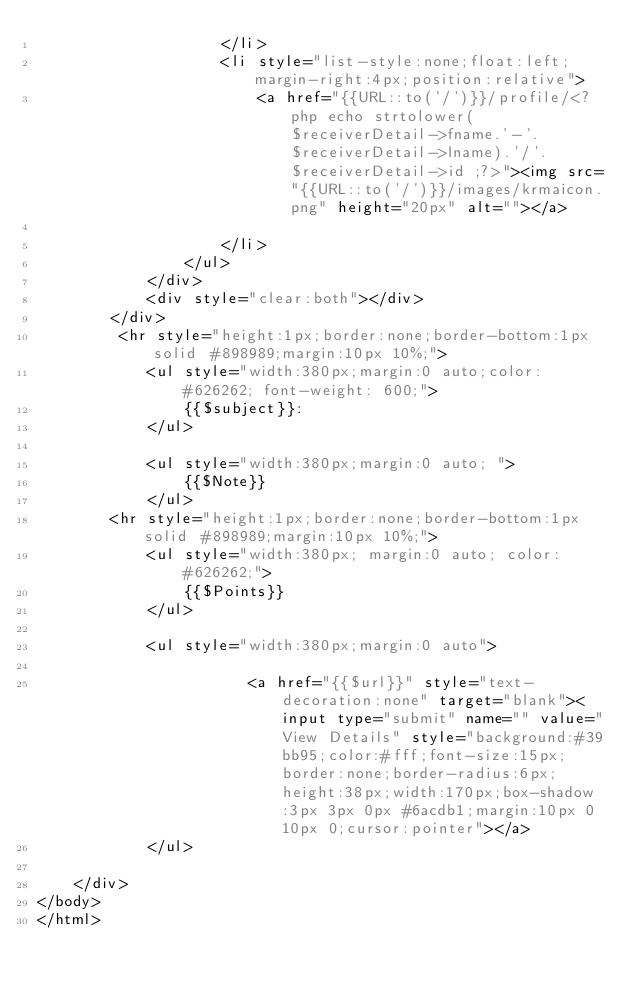Convert code to text. <code><loc_0><loc_0><loc_500><loc_500><_PHP_>					</li>
					<li style="list-style:none;float:left;margin-right:4px;position:relative">
						<a href="{{URL::to('/')}}/profile/<?php echo strtolower($receiverDetail->fname.'-'.$receiverDetail->lname).'/'.$receiverDetail->id ;?>"><img src="{{URL::to('/')}}/images/krmaicon.png" height="20px" alt=""></a>
						
					</li>
				</ul>
			</div>
			<div style="clear:both"></div>
		</div>
		 <hr style="height:1px;border:none;border-bottom:1px solid #898989;margin:10px 10%;">
			<ul style="width:380px;margin:0 auto;color: #626262; font-weight: 600;">
				{{$subject}}:  
			</ul> 
		
			<ul style="width:380px;margin:0 auto; ">
				{{$Note}} 
			</ul>
		<hr style="height:1px;border:none;border-bottom:1px solid #898989;margin:10px 10%;">
			<ul style="width:380px; margin:0 auto; color: #626262;">
				{{$Points}}
			</ul>   
 
			<ul style="width:380px;margin:0 auto"> 
                      
                       <a href="{{$url}}" style="text-decoration:none" target="blank"><input type="submit" name="" value="View Details" style="background:#39bb95;color:#fff;font-size:15px;border:none;border-radius:6px;height:38px;width:170px;box-shadow:3px 3px 0px #6acdb1;margin:10px 0 10px 0;cursor:pointer"></a>
            </ul> 
                    
	</div>	
</body>
</html>	
</code> 